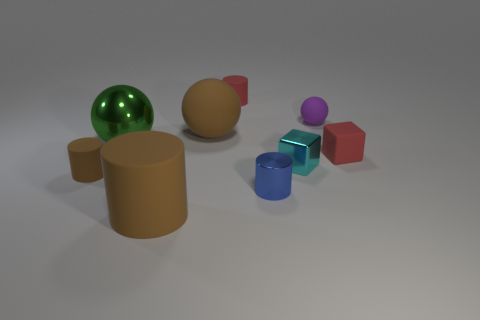Can you infer the context or purpose of this arrangement of objects? The arrangement of objects has an aesthetically pleasing, almost deliberate composition, perhaps for a display or artistic purpose. There's a sense of balance and color coordination that suggests it could be a setup for a photograph in a catalog or an educational tool for studying geometry and color theory. It doesn't seem to serve any practical function and is likely meant for visual or didactic appeal. 